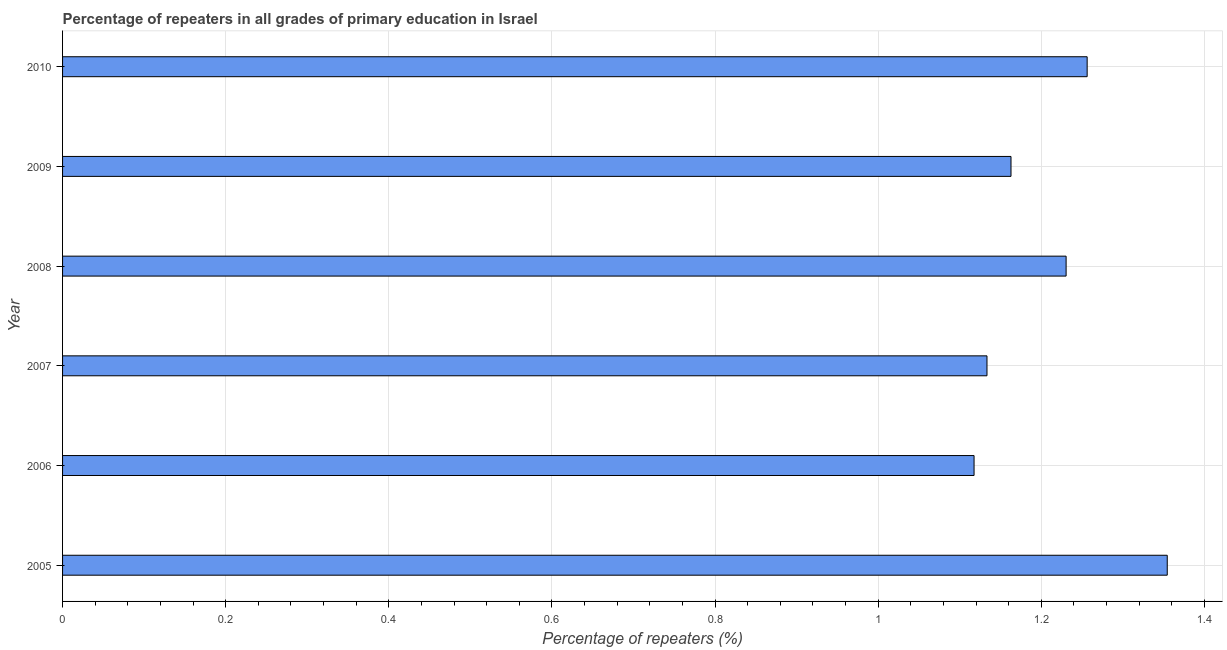Does the graph contain any zero values?
Provide a short and direct response. No. Does the graph contain grids?
Provide a succinct answer. Yes. What is the title of the graph?
Your response must be concise. Percentage of repeaters in all grades of primary education in Israel. What is the label or title of the X-axis?
Offer a terse response. Percentage of repeaters (%). What is the label or title of the Y-axis?
Your answer should be compact. Year. What is the percentage of repeaters in primary education in 2005?
Your response must be concise. 1.35. Across all years, what is the maximum percentage of repeaters in primary education?
Offer a very short reply. 1.35. Across all years, what is the minimum percentage of repeaters in primary education?
Provide a short and direct response. 1.12. In which year was the percentage of repeaters in primary education maximum?
Keep it short and to the point. 2005. In which year was the percentage of repeaters in primary education minimum?
Offer a very short reply. 2006. What is the sum of the percentage of repeaters in primary education?
Your answer should be compact. 7.25. What is the difference between the percentage of repeaters in primary education in 2005 and 2009?
Ensure brevity in your answer.  0.19. What is the average percentage of repeaters in primary education per year?
Provide a short and direct response. 1.21. What is the median percentage of repeaters in primary education?
Give a very brief answer. 1.2. Is the difference between the percentage of repeaters in primary education in 2005 and 2006 greater than the difference between any two years?
Make the answer very short. Yes. What is the difference between the highest and the second highest percentage of repeaters in primary education?
Ensure brevity in your answer.  0.1. What is the difference between the highest and the lowest percentage of repeaters in primary education?
Offer a terse response. 0.24. How many bars are there?
Your response must be concise. 6. What is the difference between two consecutive major ticks on the X-axis?
Provide a succinct answer. 0.2. Are the values on the major ticks of X-axis written in scientific E-notation?
Your answer should be compact. No. What is the Percentage of repeaters (%) of 2005?
Ensure brevity in your answer.  1.35. What is the Percentage of repeaters (%) in 2006?
Provide a succinct answer. 1.12. What is the Percentage of repeaters (%) in 2007?
Your response must be concise. 1.13. What is the Percentage of repeaters (%) in 2008?
Keep it short and to the point. 1.23. What is the Percentage of repeaters (%) of 2009?
Offer a terse response. 1.16. What is the Percentage of repeaters (%) of 2010?
Provide a short and direct response. 1.26. What is the difference between the Percentage of repeaters (%) in 2005 and 2006?
Keep it short and to the point. 0.24. What is the difference between the Percentage of repeaters (%) in 2005 and 2007?
Provide a short and direct response. 0.22. What is the difference between the Percentage of repeaters (%) in 2005 and 2008?
Keep it short and to the point. 0.12. What is the difference between the Percentage of repeaters (%) in 2005 and 2009?
Ensure brevity in your answer.  0.19. What is the difference between the Percentage of repeaters (%) in 2005 and 2010?
Provide a succinct answer. 0.1. What is the difference between the Percentage of repeaters (%) in 2006 and 2007?
Your answer should be compact. -0.02. What is the difference between the Percentage of repeaters (%) in 2006 and 2008?
Ensure brevity in your answer.  -0.11. What is the difference between the Percentage of repeaters (%) in 2006 and 2009?
Ensure brevity in your answer.  -0.05. What is the difference between the Percentage of repeaters (%) in 2006 and 2010?
Your response must be concise. -0.14. What is the difference between the Percentage of repeaters (%) in 2007 and 2008?
Offer a very short reply. -0.1. What is the difference between the Percentage of repeaters (%) in 2007 and 2009?
Offer a terse response. -0.03. What is the difference between the Percentage of repeaters (%) in 2007 and 2010?
Give a very brief answer. -0.12. What is the difference between the Percentage of repeaters (%) in 2008 and 2009?
Your answer should be very brief. 0.07. What is the difference between the Percentage of repeaters (%) in 2008 and 2010?
Offer a terse response. -0.03. What is the difference between the Percentage of repeaters (%) in 2009 and 2010?
Provide a succinct answer. -0.09. What is the ratio of the Percentage of repeaters (%) in 2005 to that in 2006?
Offer a terse response. 1.21. What is the ratio of the Percentage of repeaters (%) in 2005 to that in 2007?
Your answer should be compact. 1.2. What is the ratio of the Percentage of repeaters (%) in 2005 to that in 2008?
Offer a terse response. 1.1. What is the ratio of the Percentage of repeaters (%) in 2005 to that in 2009?
Your response must be concise. 1.17. What is the ratio of the Percentage of repeaters (%) in 2005 to that in 2010?
Your response must be concise. 1.08. What is the ratio of the Percentage of repeaters (%) in 2006 to that in 2008?
Your answer should be very brief. 0.91. What is the ratio of the Percentage of repeaters (%) in 2006 to that in 2009?
Make the answer very short. 0.96. What is the ratio of the Percentage of repeaters (%) in 2006 to that in 2010?
Your answer should be compact. 0.89. What is the ratio of the Percentage of repeaters (%) in 2007 to that in 2008?
Your answer should be very brief. 0.92. What is the ratio of the Percentage of repeaters (%) in 2007 to that in 2009?
Ensure brevity in your answer.  0.97. What is the ratio of the Percentage of repeaters (%) in 2007 to that in 2010?
Make the answer very short. 0.9. What is the ratio of the Percentage of repeaters (%) in 2008 to that in 2009?
Keep it short and to the point. 1.06. What is the ratio of the Percentage of repeaters (%) in 2008 to that in 2010?
Keep it short and to the point. 0.98. What is the ratio of the Percentage of repeaters (%) in 2009 to that in 2010?
Provide a short and direct response. 0.93. 